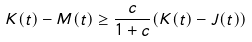<formula> <loc_0><loc_0><loc_500><loc_500>K ( t ) - M ( t ) \geq \frac { c } { 1 + c } ( K ( t ) - J ( t ) )</formula> 